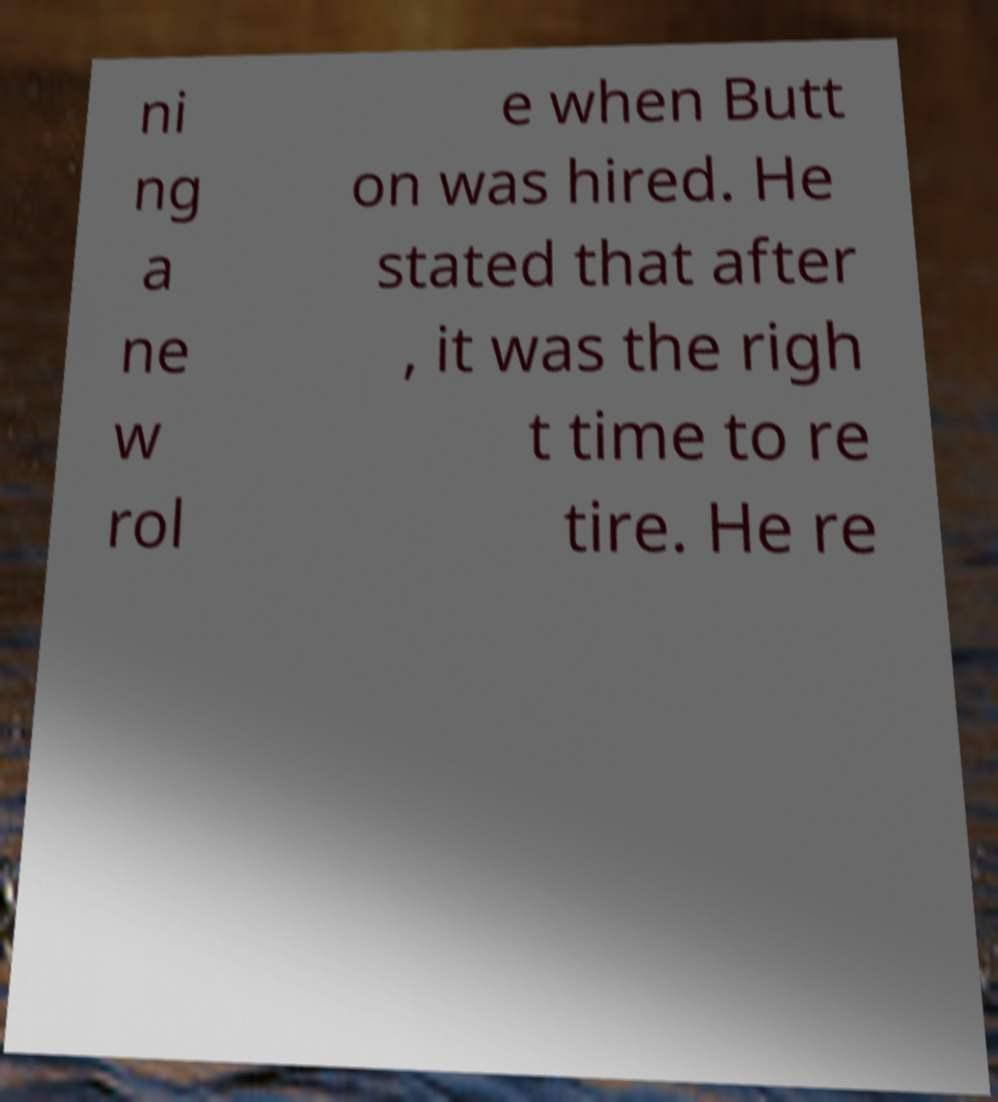Could you assist in decoding the text presented in this image and type it out clearly? ni ng a ne w rol e when Butt on was hired. He stated that after , it was the righ t time to re tire. He re 